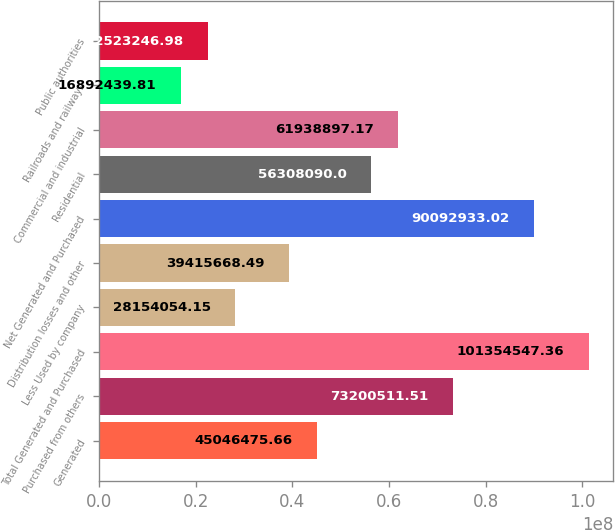Convert chart. <chart><loc_0><loc_0><loc_500><loc_500><bar_chart><fcel>Generated<fcel>Purchased from others<fcel>Total Generated and Purchased<fcel>Less Used by company<fcel>Distribution losses and other<fcel>Net Generated and Purchased<fcel>Residential<fcel>Commercial and industrial<fcel>Railroads and railways<fcel>Public authorities<nl><fcel>4.50465e+07<fcel>7.32005e+07<fcel>1.01355e+08<fcel>2.81541e+07<fcel>3.94157e+07<fcel>9.00929e+07<fcel>5.63081e+07<fcel>6.19389e+07<fcel>1.68924e+07<fcel>2.25232e+07<nl></chart> 